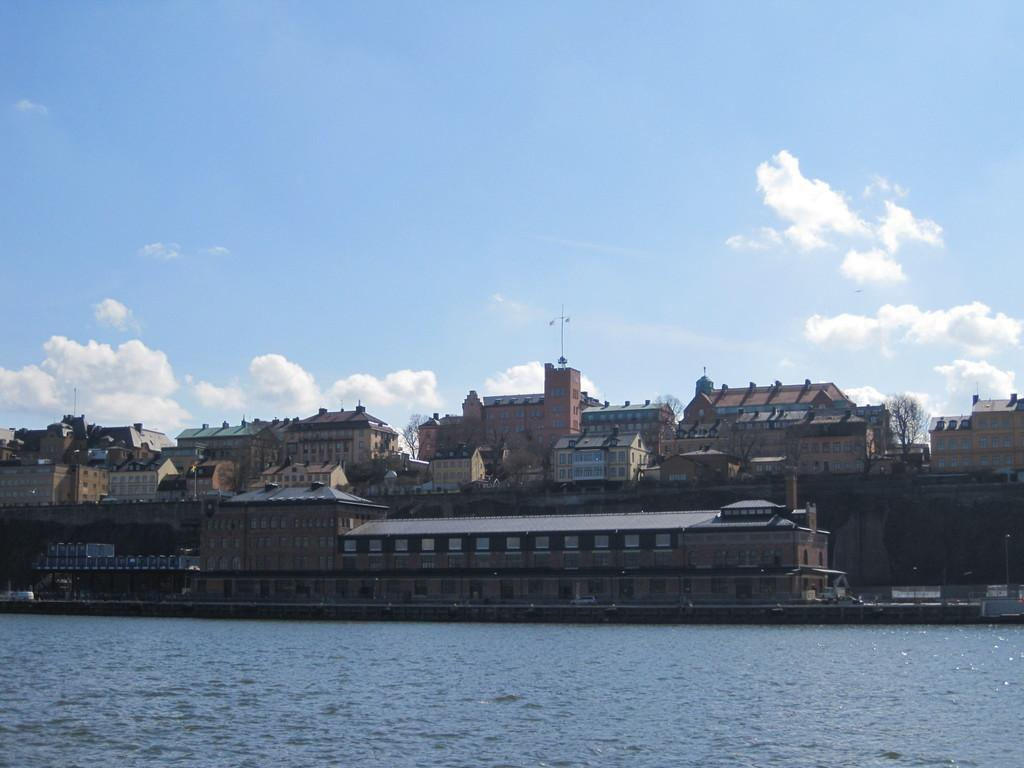What natural feature is present in the image? There is a river in the picture. What type of structures can be seen in the background? There are buildings in the backdrop of the picture. What type of vegetation is present in the background? There are trees in the backdrop of the picture. What feature do the buildings have? The buildings have windows. What is the condition of the sky in the image? The sky is clear in the image. Reasoning: Let' Let's think step by step in order to produce the conversation. We start by identifying the main natural feature in the image, which is the river. Then, we describe the background of the image, mentioning the presence of buildings and trees. We also note the presence of windows on the buildings and the clear sky. Each question is designed to elicit a specific detail about the image that is known from the provided facts. Absurd Question/Answer: What type of camera is being used to take the picture of the jail in the image? There is no jail present in the image, and no camera is visible. 